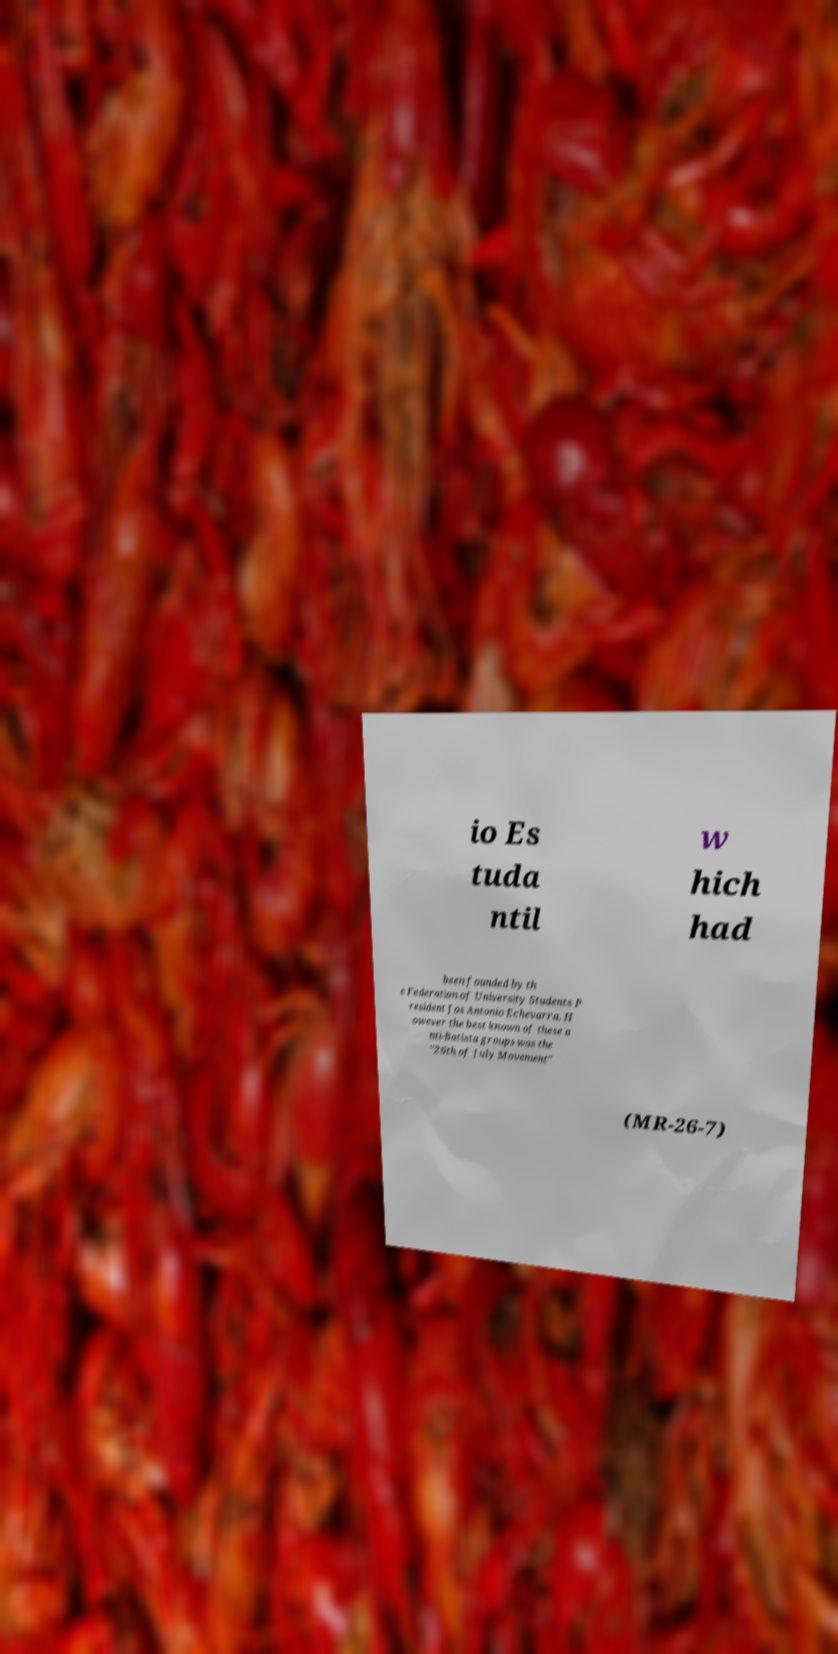Please identify and transcribe the text found in this image. io Es tuda ntil w hich had been founded by th e Federation of University Students P resident Jos Antonio Echevarra. H owever the best known of these a nti-Batista groups was the "26th of July Movement" (MR-26-7) 